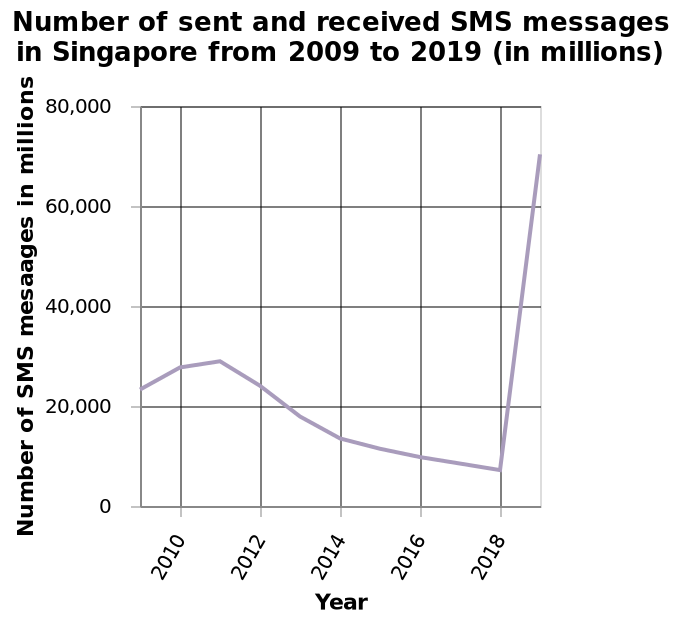<image>
What is the time period covered in the line chart? The time period covered in the line chart is from 2009 to 2019. 